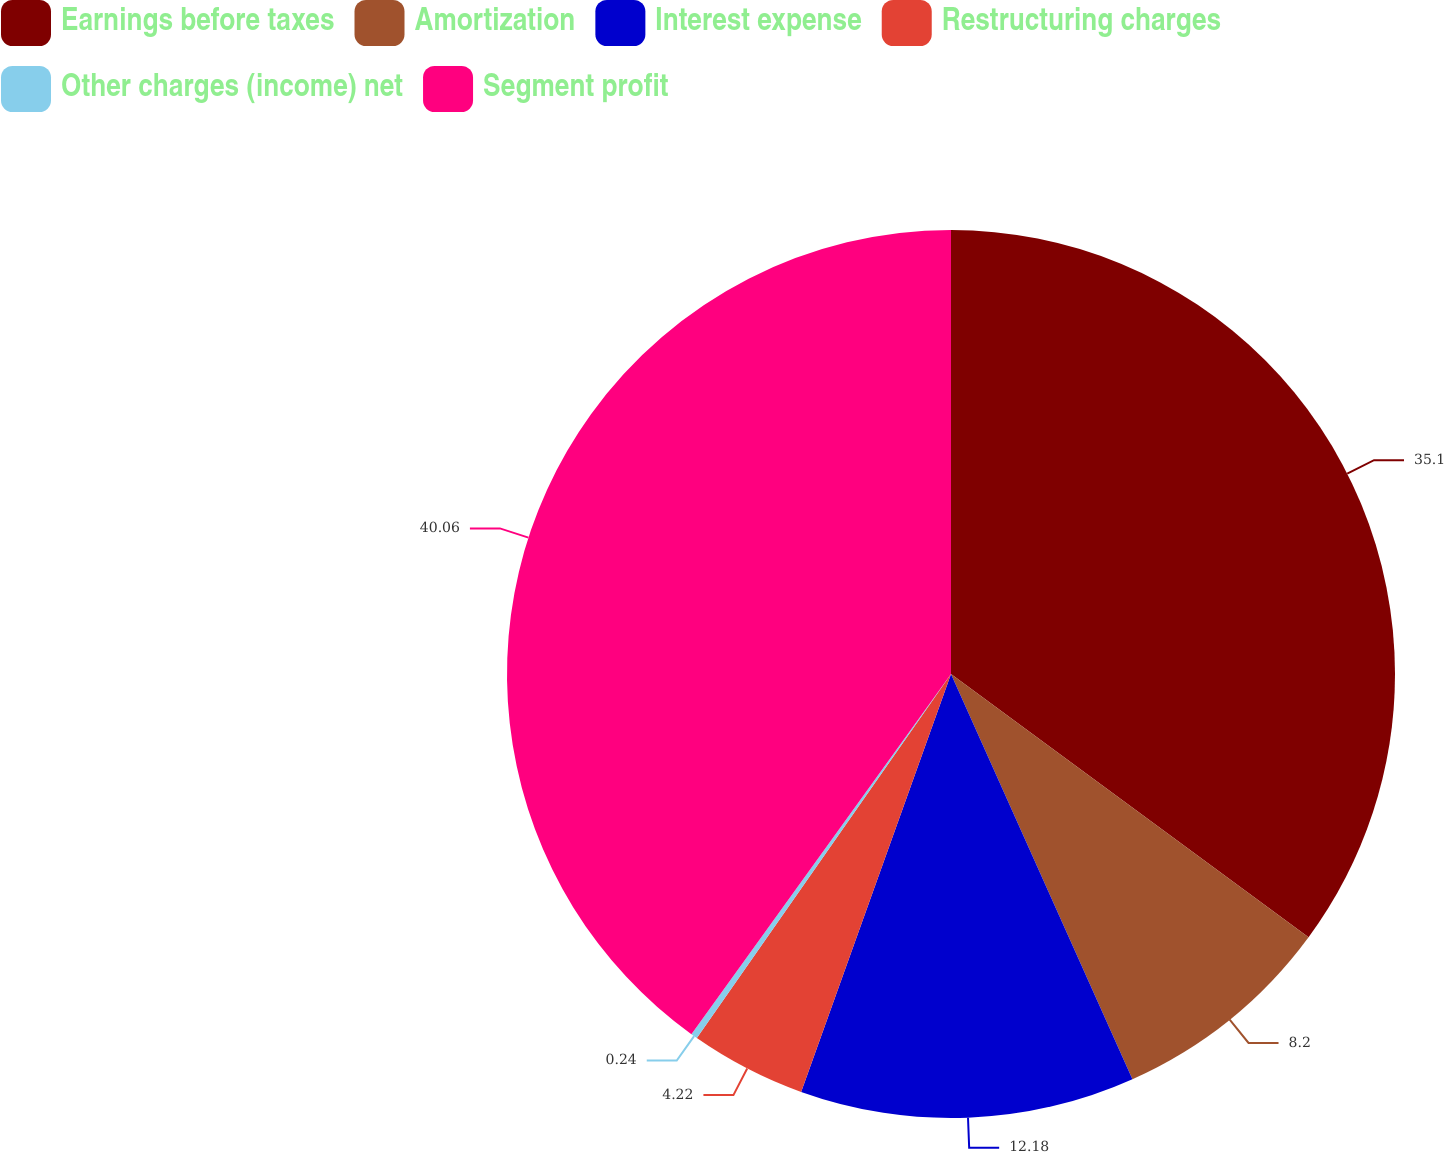Convert chart to OTSL. <chart><loc_0><loc_0><loc_500><loc_500><pie_chart><fcel>Earnings before taxes<fcel>Amortization<fcel>Interest expense<fcel>Restructuring charges<fcel>Other charges (income) net<fcel>Segment profit<nl><fcel>35.1%<fcel>8.2%<fcel>12.18%<fcel>4.22%<fcel>0.24%<fcel>40.06%<nl></chart> 